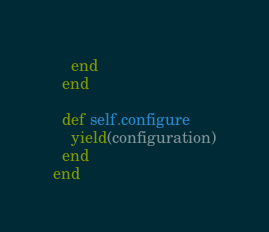<code> <loc_0><loc_0><loc_500><loc_500><_Ruby_>    end
  end

  def self.configure
    yield(configuration)
  end
end
</code> 